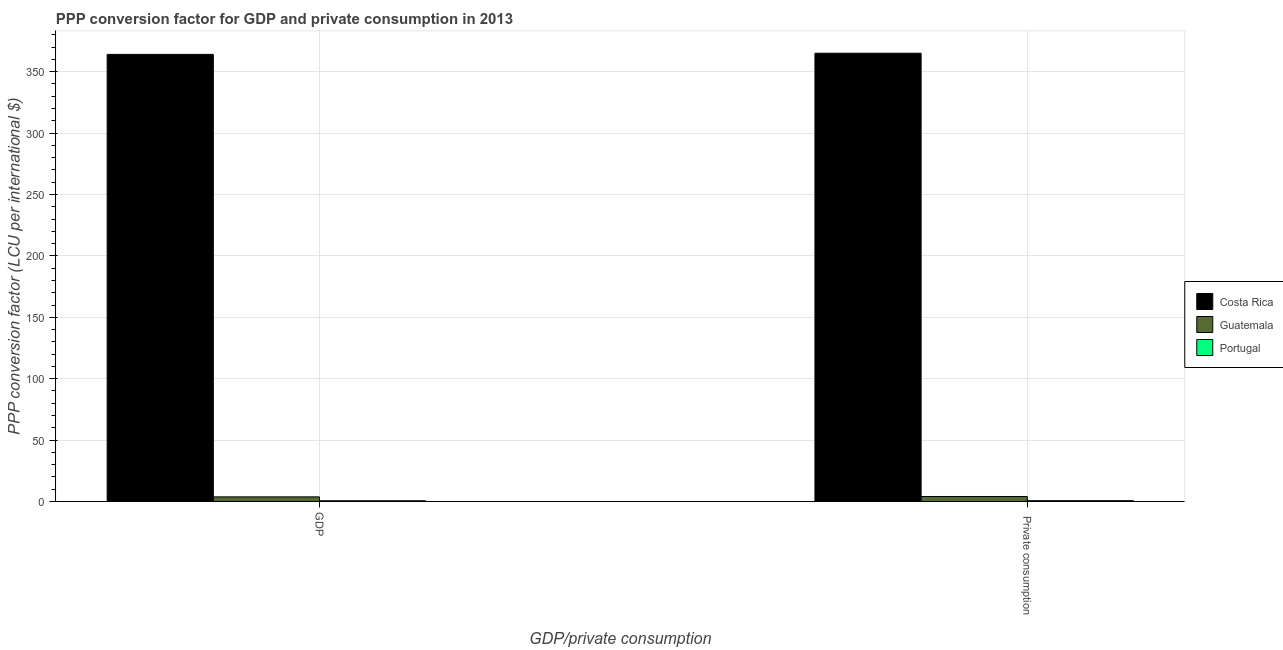How many groups of bars are there?
Your answer should be compact. 2. Are the number of bars per tick equal to the number of legend labels?
Make the answer very short. Yes. How many bars are there on the 2nd tick from the left?
Your answer should be very brief. 3. How many bars are there on the 1st tick from the right?
Your answer should be very brief. 3. What is the label of the 1st group of bars from the left?
Give a very brief answer. GDP. What is the ppp conversion factor for private consumption in Portugal?
Provide a succinct answer. 0.66. Across all countries, what is the maximum ppp conversion factor for private consumption?
Provide a succinct answer. 365.03. Across all countries, what is the minimum ppp conversion factor for private consumption?
Offer a terse response. 0.66. In which country was the ppp conversion factor for gdp minimum?
Offer a terse response. Portugal. What is the total ppp conversion factor for private consumption in the graph?
Make the answer very short. 369.74. What is the difference between the ppp conversion factor for gdp in Guatemala and that in Portugal?
Offer a terse response. 3.16. What is the difference between the ppp conversion factor for gdp in Costa Rica and the ppp conversion factor for private consumption in Guatemala?
Give a very brief answer. 360.03. What is the average ppp conversion factor for gdp per country?
Your answer should be compact. 122.81. What is the difference between the ppp conversion factor for private consumption and ppp conversion factor for gdp in Portugal?
Your answer should be compact. 0.07. What is the ratio of the ppp conversion factor for private consumption in Costa Rica to that in Guatemala?
Offer a very short reply. 90.13. What does the 3rd bar from the left in GDP represents?
Keep it short and to the point. Portugal. What does the 1st bar from the right in GDP represents?
Provide a succinct answer. Portugal. Does the graph contain any zero values?
Keep it short and to the point. No. Does the graph contain grids?
Your response must be concise. Yes. How many legend labels are there?
Offer a terse response. 3. How are the legend labels stacked?
Offer a very short reply. Vertical. What is the title of the graph?
Make the answer very short. PPP conversion factor for GDP and private consumption in 2013. What is the label or title of the X-axis?
Ensure brevity in your answer.  GDP/private consumption. What is the label or title of the Y-axis?
Provide a short and direct response. PPP conversion factor (LCU per international $). What is the PPP conversion factor (LCU per international $) of Costa Rica in GDP?
Offer a terse response. 364.08. What is the PPP conversion factor (LCU per international $) in Guatemala in GDP?
Provide a short and direct response. 3.75. What is the PPP conversion factor (LCU per international $) of Portugal in GDP?
Your answer should be compact. 0.59. What is the PPP conversion factor (LCU per international $) of Costa Rica in  Private consumption?
Offer a terse response. 365.03. What is the PPP conversion factor (LCU per international $) in Guatemala in  Private consumption?
Offer a terse response. 4.05. What is the PPP conversion factor (LCU per international $) of Portugal in  Private consumption?
Offer a terse response. 0.66. Across all GDP/private consumption, what is the maximum PPP conversion factor (LCU per international $) of Costa Rica?
Provide a short and direct response. 365.03. Across all GDP/private consumption, what is the maximum PPP conversion factor (LCU per international $) of Guatemala?
Your answer should be very brief. 4.05. Across all GDP/private consumption, what is the maximum PPP conversion factor (LCU per international $) in Portugal?
Offer a terse response. 0.66. Across all GDP/private consumption, what is the minimum PPP conversion factor (LCU per international $) in Costa Rica?
Provide a short and direct response. 364.08. Across all GDP/private consumption, what is the minimum PPP conversion factor (LCU per international $) of Guatemala?
Offer a terse response. 3.75. Across all GDP/private consumption, what is the minimum PPP conversion factor (LCU per international $) of Portugal?
Keep it short and to the point. 0.59. What is the total PPP conversion factor (LCU per international $) in Costa Rica in the graph?
Your response must be concise. 729.11. What is the total PPP conversion factor (LCU per international $) in Guatemala in the graph?
Provide a succinct answer. 7.8. What is the total PPP conversion factor (LCU per international $) in Portugal in the graph?
Your response must be concise. 1.25. What is the difference between the PPP conversion factor (LCU per international $) in Costa Rica in GDP and that in  Private consumption?
Provide a short and direct response. -0.95. What is the difference between the PPP conversion factor (LCU per international $) in Guatemala in GDP and that in  Private consumption?
Offer a very short reply. -0.3. What is the difference between the PPP conversion factor (LCU per international $) in Portugal in GDP and that in  Private consumption?
Offer a terse response. -0.07. What is the difference between the PPP conversion factor (LCU per international $) of Costa Rica in GDP and the PPP conversion factor (LCU per international $) of Guatemala in  Private consumption?
Your response must be concise. 360.03. What is the difference between the PPP conversion factor (LCU per international $) in Costa Rica in GDP and the PPP conversion factor (LCU per international $) in Portugal in  Private consumption?
Keep it short and to the point. 363.42. What is the difference between the PPP conversion factor (LCU per international $) in Guatemala in GDP and the PPP conversion factor (LCU per international $) in Portugal in  Private consumption?
Your response must be concise. 3.09. What is the average PPP conversion factor (LCU per international $) in Costa Rica per GDP/private consumption?
Your answer should be compact. 364.55. What is the average PPP conversion factor (LCU per international $) in Guatemala per GDP/private consumption?
Offer a very short reply. 3.9. What is the average PPP conversion factor (LCU per international $) of Portugal per GDP/private consumption?
Offer a terse response. 0.62. What is the difference between the PPP conversion factor (LCU per international $) in Costa Rica and PPP conversion factor (LCU per international $) in Guatemala in GDP?
Make the answer very short. 360.33. What is the difference between the PPP conversion factor (LCU per international $) in Costa Rica and PPP conversion factor (LCU per international $) in Portugal in GDP?
Offer a terse response. 363.49. What is the difference between the PPP conversion factor (LCU per international $) in Guatemala and PPP conversion factor (LCU per international $) in Portugal in GDP?
Offer a very short reply. 3.16. What is the difference between the PPP conversion factor (LCU per international $) of Costa Rica and PPP conversion factor (LCU per international $) of Guatemala in  Private consumption?
Give a very brief answer. 360.98. What is the difference between the PPP conversion factor (LCU per international $) of Costa Rica and PPP conversion factor (LCU per international $) of Portugal in  Private consumption?
Offer a very short reply. 364.37. What is the difference between the PPP conversion factor (LCU per international $) of Guatemala and PPP conversion factor (LCU per international $) of Portugal in  Private consumption?
Provide a succinct answer. 3.39. What is the ratio of the PPP conversion factor (LCU per international $) of Costa Rica in GDP to that in  Private consumption?
Provide a short and direct response. 1. What is the ratio of the PPP conversion factor (LCU per international $) of Guatemala in GDP to that in  Private consumption?
Your response must be concise. 0.93. What is the ratio of the PPP conversion factor (LCU per international $) of Portugal in GDP to that in  Private consumption?
Offer a very short reply. 0.89. What is the difference between the highest and the second highest PPP conversion factor (LCU per international $) of Costa Rica?
Give a very brief answer. 0.95. What is the difference between the highest and the second highest PPP conversion factor (LCU per international $) in Guatemala?
Offer a very short reply. 0.3. What is the difference between the highest and the second highest PPP conversion factor (LCU per international $) in Portugal?
Provide a short and direct response. 0.07. What is the difference between the highest and the lowest PPP conversion factor (LCU per international $) of Costa Rica?
Ensure brevity in your answer.  0.95. What is the difference between the highest and the lowest PPP conversion factor (LCU per international $) of Guatemala?
Offer a terse response. 0.3. What is the difference between the highest and the lowest PPP conversion factor (LCU per international $) in Portugal?
Ensure brevity in your answer.  0.07. 